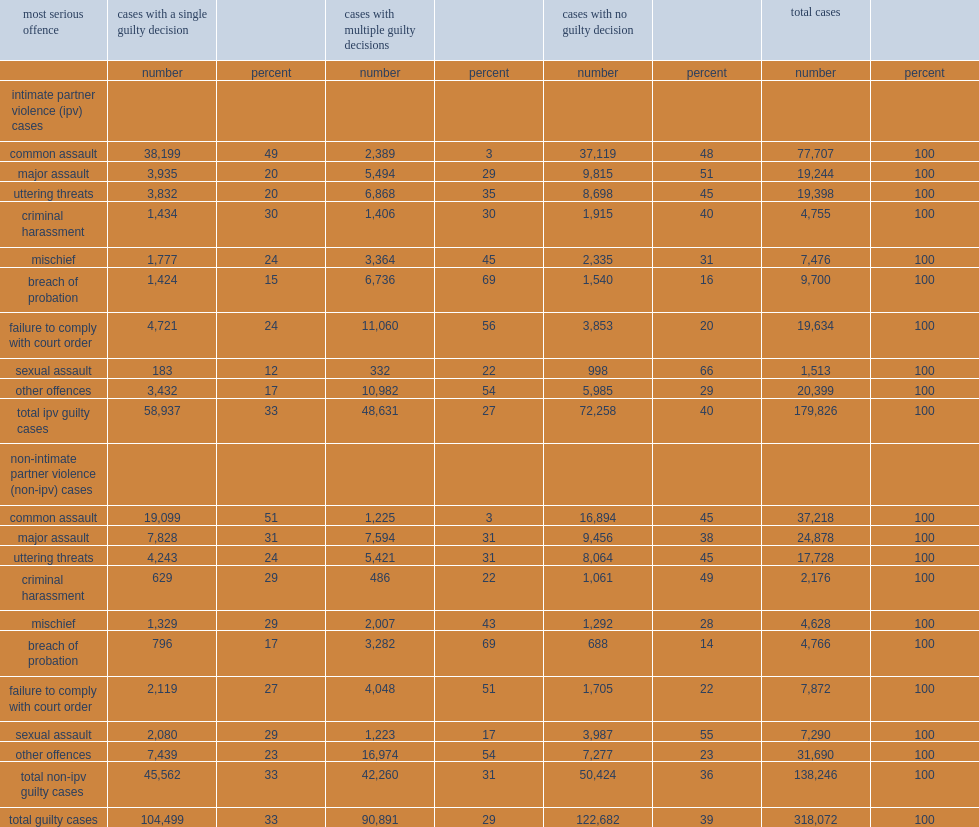For cases involving common assault, what percent of ipv cases resulted in a guilty finding? 52. Which guilty decision is the predomianted decision among common assault cases, whether ipv on non-ipv related. Cases with a single guilty decision. What percent of accused in non-ipv major assault cases were found guilty? 62. Which type of sexual assault cases was more likely to be found guilty? Non-intimate partner violence (non-ipv) cases. Among ipv cases, what percent of criminal harassment resulted in a guilty finding. 60. 